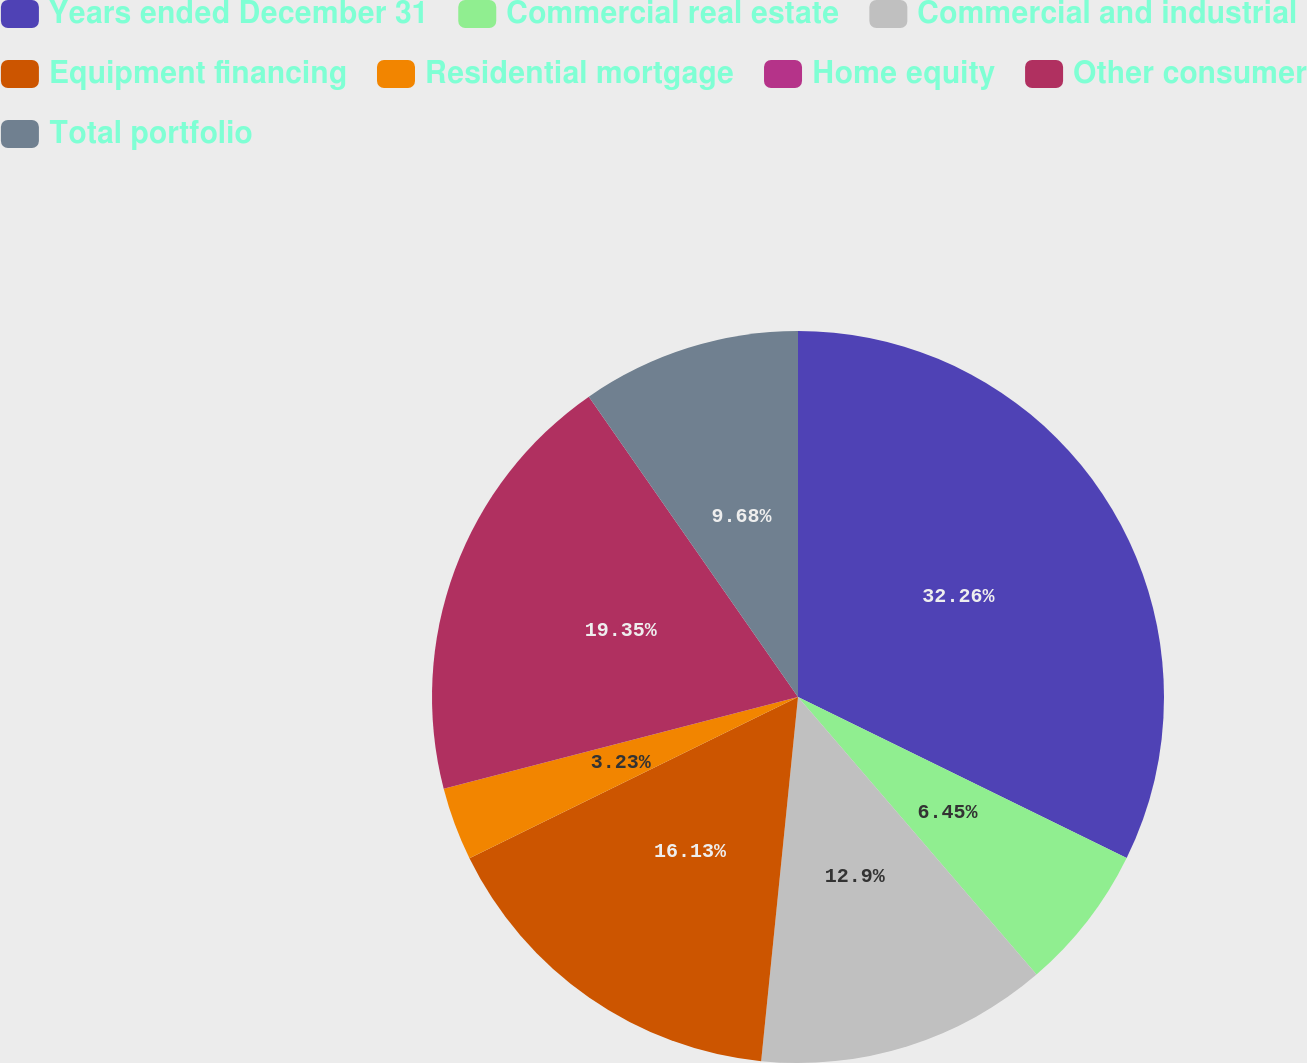Convert chart. <chart><loc_0><loc_0><loc_500><loc_500><pie_chart><fcel>Years ended December 31<fcel>Commercial real estate<fcel>Commercial and industrial<fcel>Equipment financing<fcel>Residential mortgage<fcel>Home equity<fcel>Other consumer<fcel>Total portfolio<nl><fcel>32.25%<fcel>6.45%<fcel>12.9%<fcel>16.13%<fcel>3.23%<fcel>0.0%<fcel>19.35%<fcel>9.68%<nl></chart> 